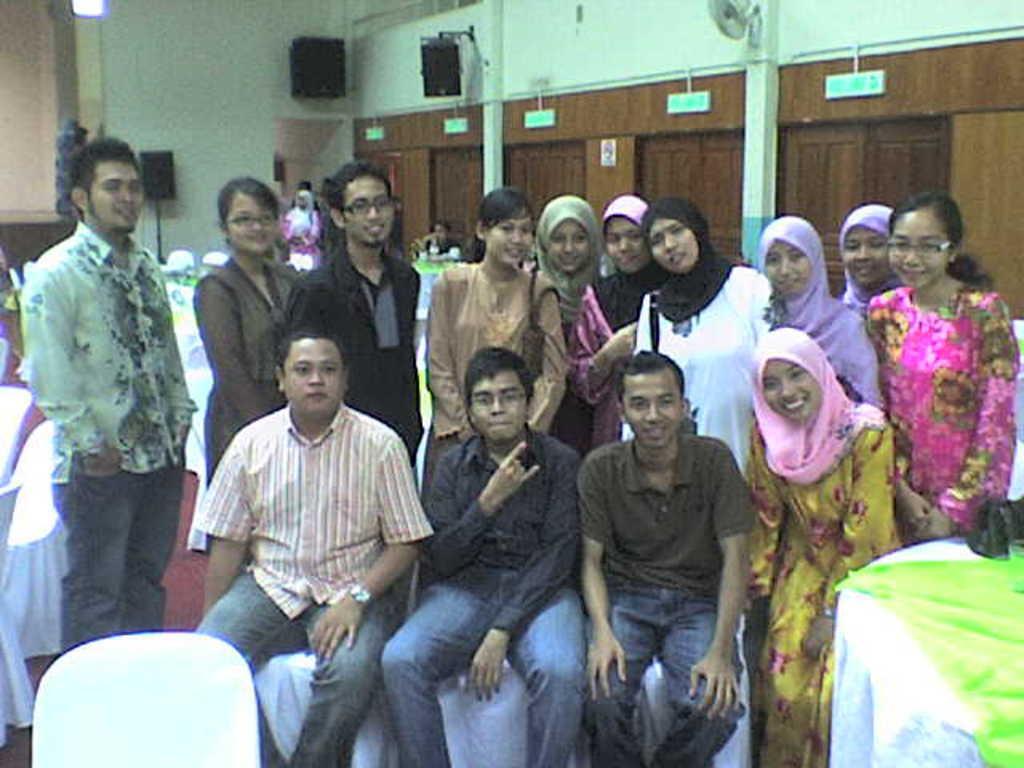In one or two sentences, can you explain what this image depicts? In this picture I can see group of people among them some are standing and some are sitting on chairs. In the background I can see a white color wall, poles and wooden wall. I can also see black color objects. On the left side I can see chairs on which white color clothes are covered. 